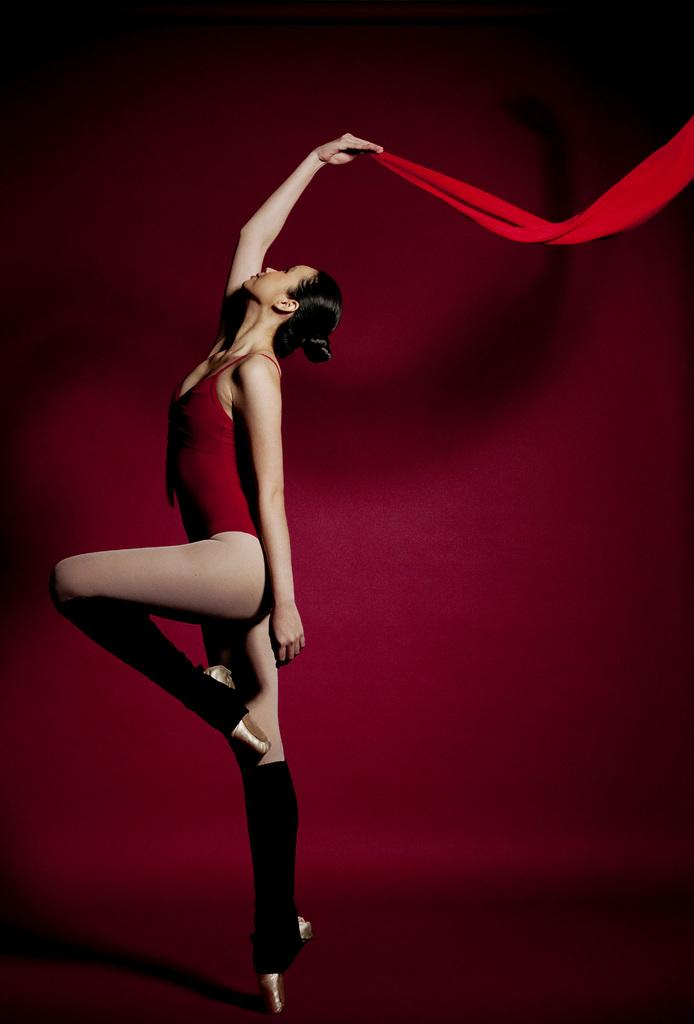Who is the main subject in the image? There is a woman in the image. What is the woman wearing? The woman is wearing a red dress. What is the woman holding in the image? The woman is holding a red cloth. What is the color of the background in the image? The background of the image is red. What type of food is the woman preparing with the red cloth in the image? There is no indication in the image that the woman is preparing food or using the red cloth for that purpose. 